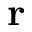<formula> <loc_0><loc_0><loc_500><loc_500>r</formula> 